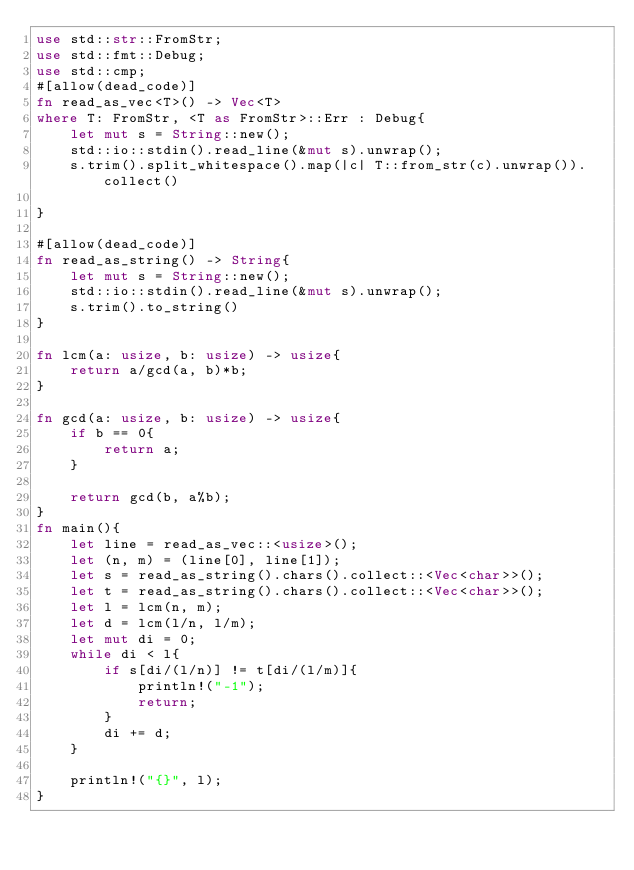Convert code to text. <code><loc_0><loc_0><loc_500><loc_500><_Rust_>use std::str::FromStr;
use std::fmt::Debug;
use std::cmp;
#[allow(dead_code)]
fn read_as_vec<T>() -> Vec<T>
where T: FromStr, <T as FromStr>::Err : Debug{
    let mut s = String::new();
    std::io::stdin().read_line(&mut s).unwrap();
    s.trim().split_whitespace().map(|c| T::from_str(c).unwrap()).collect()

}

#[allow(dead_code)]
fn read_as_string() -> String{
    let mut s = String::new();
    std::io::stdin().read_line(&mut s).unwrap();
    s.trim().to_string()
}

fn lcm(a: usize, b: usize) -> usize{
    return a/gcd(a, b)*b;
}

fn gcd(a: usize, b: usize) -> usize{
    if b == 0{
        return a;
    }

    return gcd(b, a%b);
}
fn main(){
    let line = read_as_vec::<usize>();
    let (n, m) = (line[0], line[1]);
    let s = read_as_string().chars().collect::<Vec<char>>();
    let t = read_as_string().chars().collect::<Vec<char>>();
    let l = lcm(n, m);
    let d = lcm(l/n, l/m);
    let mut di = 0;
    while di < l{
        if s[di/(l/n)] != t[di/(l/m)]{
            println!("-1");
            return;
        }
        di += d;
    }

    println!("{}", l);
}
</code> 